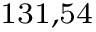<formula> <loc_0><loc_0><loc_500><loc_500>^ { 1 } 3 1 , 5 4</formula> 